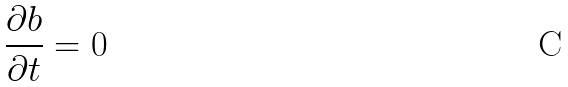Convert formula to latex. <formula><loc_0><loc_0><loc_500><loc_500>\frac { \partial b } { \partial t } = 0</formula> 